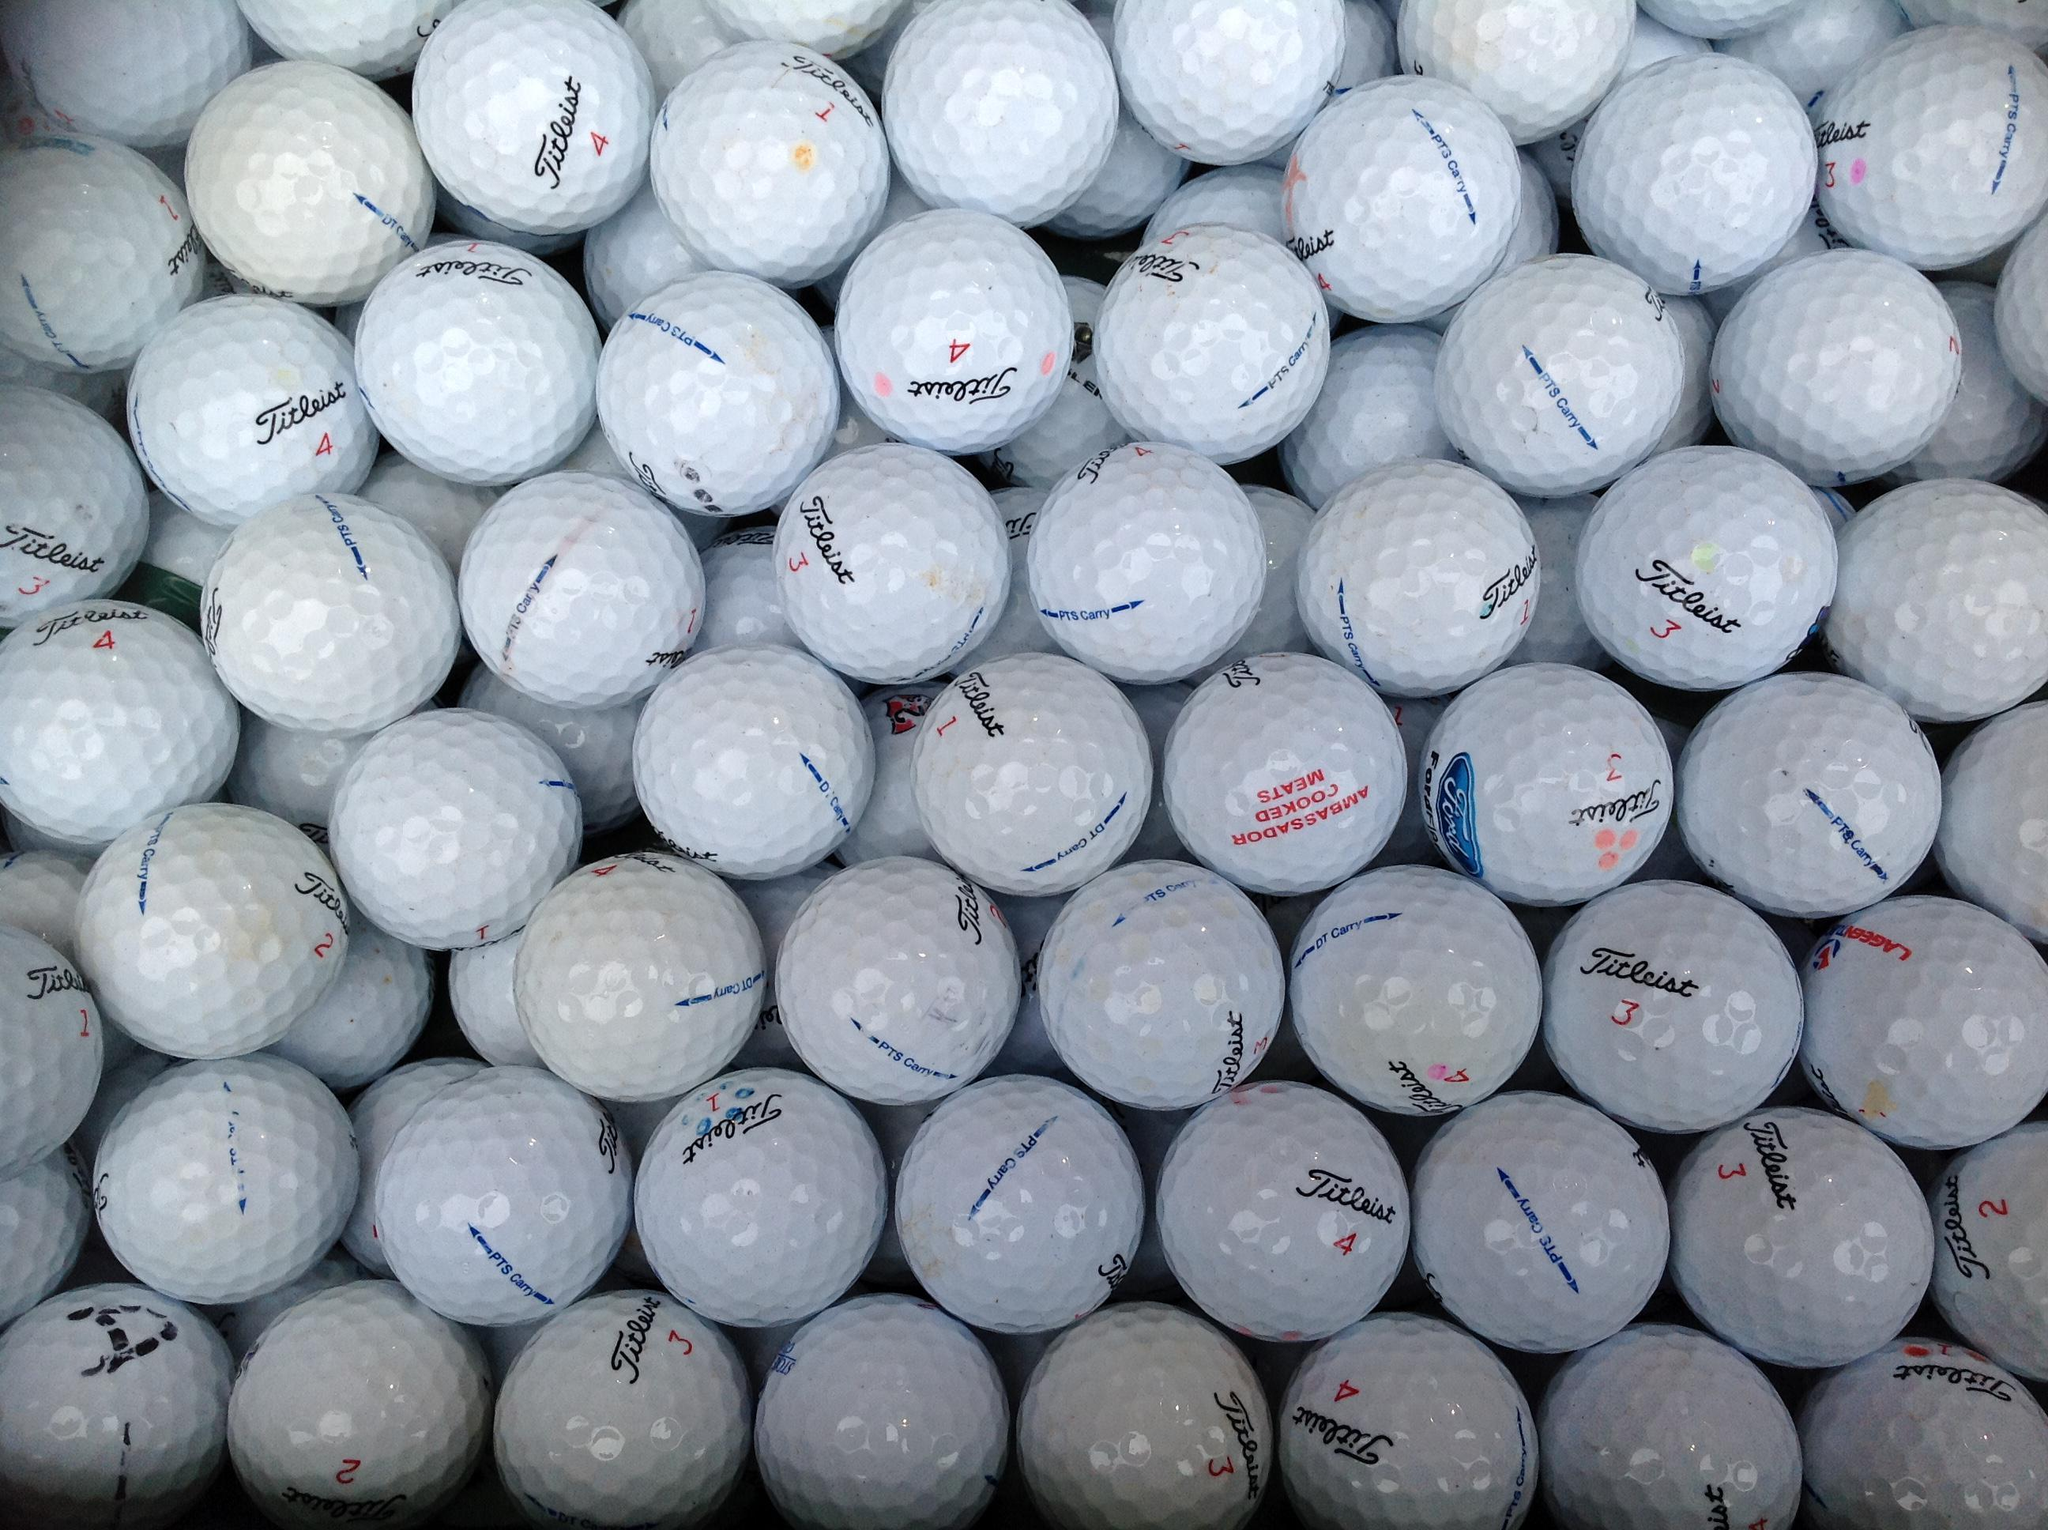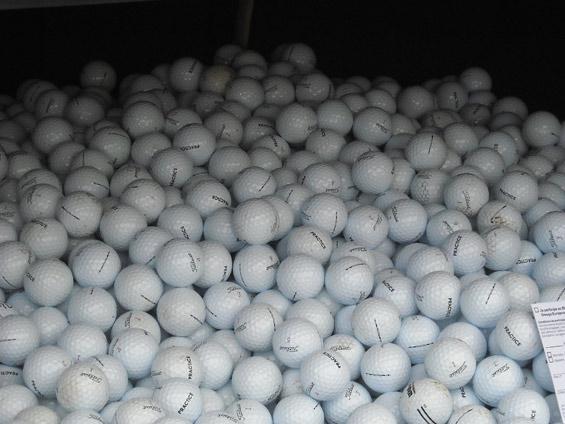The first image is the image on the left, the second image is the image on the right. For the images displayed, is the sentence "None of the balls are in shadow in one of the images." factually correct? Answer yes or no. No. 